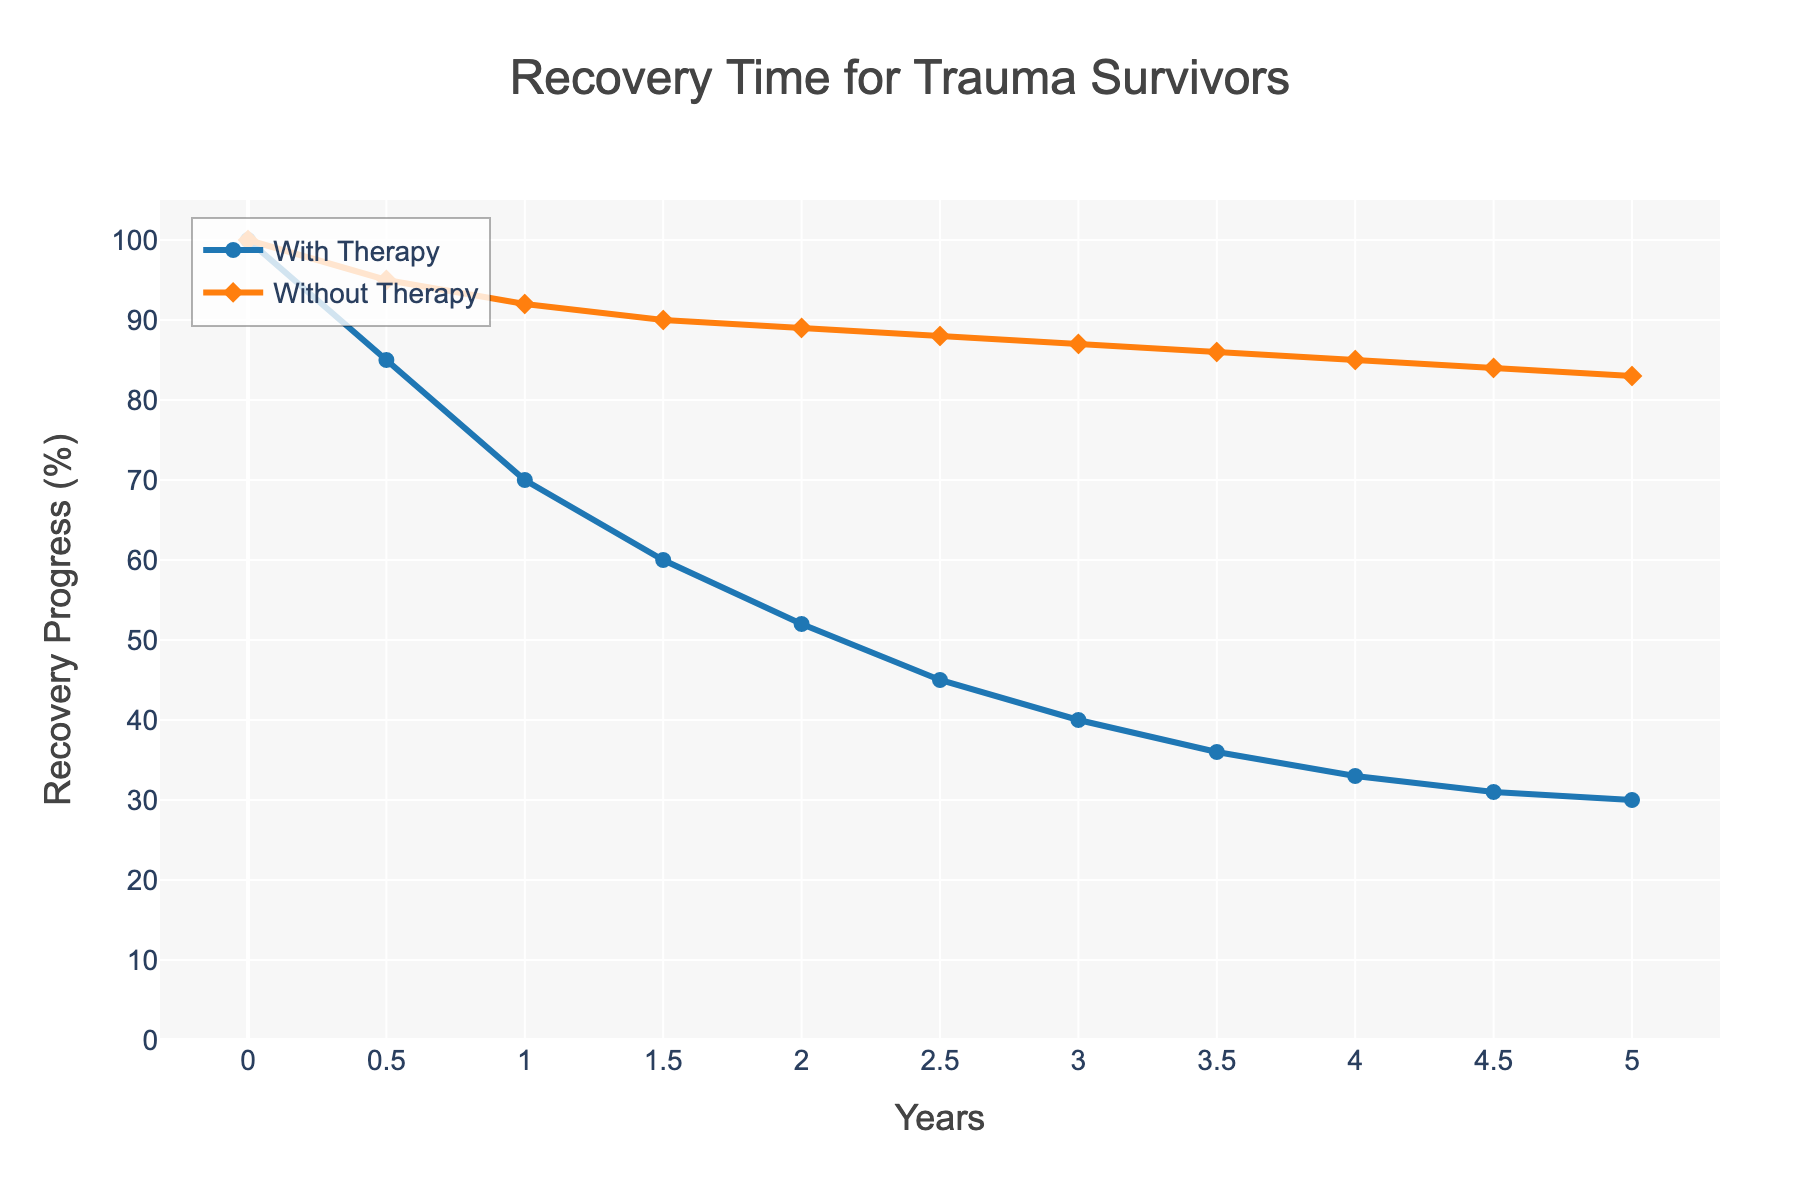Which group shows a greater improvement in recovery progress from Year 0 to Year 1? To determine which group shows greater improvement, subtract the recovery progress at Year 1 from Year 0 for both groups. For "With Therapy", it's 100 - 70 = 30. For "Without Therapy", it's 100 - 92 = 8.
Answer: With Therapy At Year 5, what is the difference in recovery progress between the two groups? Subtract the recovery progress of the "Without Therapy" group from the "With Therapy" group at Year 5. That's 30 - 83 = -53.
Answer: -53 How does the recovery progress of the "Without Therapy" group change from Year 2 to Year 4? Subtract the recovery progress at Year 4 from Year 2 for the "Without Therapy" group. That's 89 - 85 = 4.
Answer: 4 During which year does the "With Therapy" group show the steepest decline in recovery progress? Look for the largest decrease in recovery progress between consecutive data points for the "With Therapy" group. The largest decline is from Year 0.5 to Year 1, where it dropped from 85 to 70 (a decline of 15).
Answer: Year 0.5 to 1 Compare the overall trend in recovery progress between the "With Therapy" and "Without Therapy" groups over the 5-year period. Visually inspect the general direction of the lines. The "With Therapy" group has a steeper and more consistent decline in recovery progress compared to the "Without Therapy" group, which decreases more gradually.
Answer: "With Therapy" declines more steeply Is there any point where the recovery progress for both groups is equal? Visually inspect the graph to see if the lines intersect. The lines do not intersect at any point, so there is no year where recovery progress for both groups is equal.
Answer: No Between Year 1 and Year 3, how much has the recovery progress for the "With Therapy" group decreased? Subtract the recovery progress at Year 3 from Year 1 for the "With Therapy" group. That's 70 - 40 = 30.
Answer: 30 What is the average recovery progress of the "With Therapy" group over the 5-year period? Add all the recovery progress values for the "With Therapy" group and then divide by the number of data points. (100 + 85 + 70 + 60 + 52 + 45 + 40 + 36 + 33 + 31 + 30) / 11 = 52.55
Answer: 52.55 By how much did the recovery progress improve for the "Without Therapy" group from Year 0 to Year 0.5? Subtract the recovery progress at Year 0.5 from Year 0 for the "Without Therapy" group. That's 100 - 95 = 5.
Answer: 5 